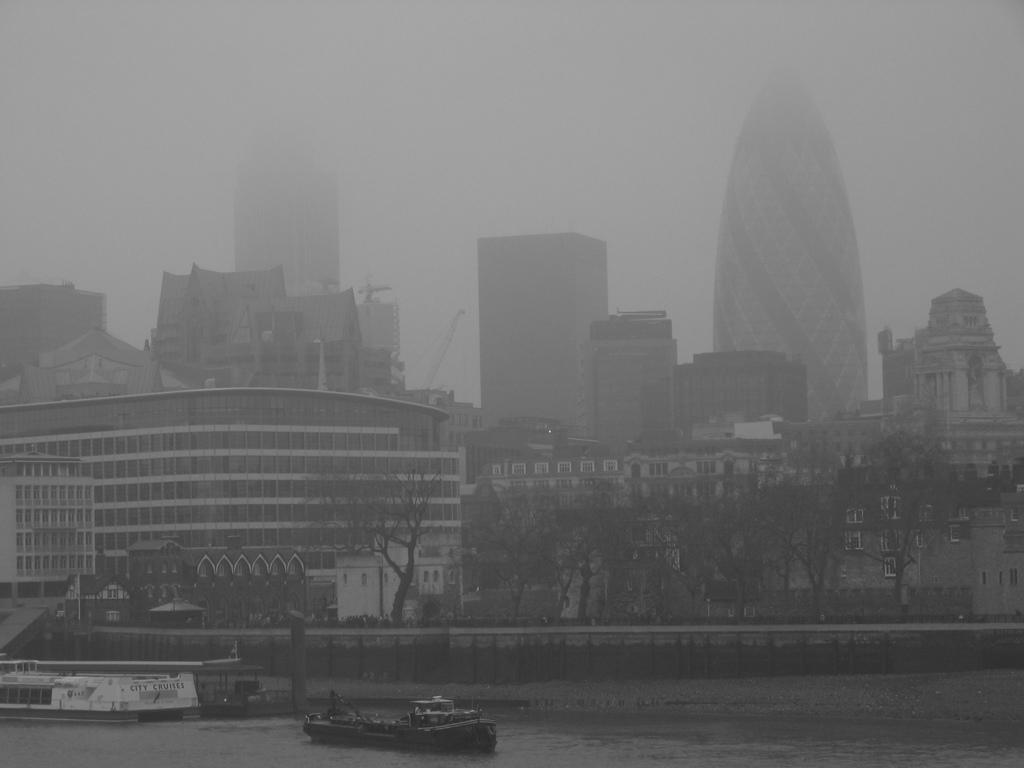What type of vehicles can be seen on the water in the image? There are boats on the water in the image. What type of natural vegetation is visible in the image? Trees are visible in the image. What type of man-made structures can be seen in the image? Buildings are present in the image. What is visible in the background of the image? The sky is visible in the background of the image. What type of fruit can be seen hanging from the trees in the image? There is no fruit visible in the image; only trees are present. How many balls are visible in the image? There are no balls present in the image. 